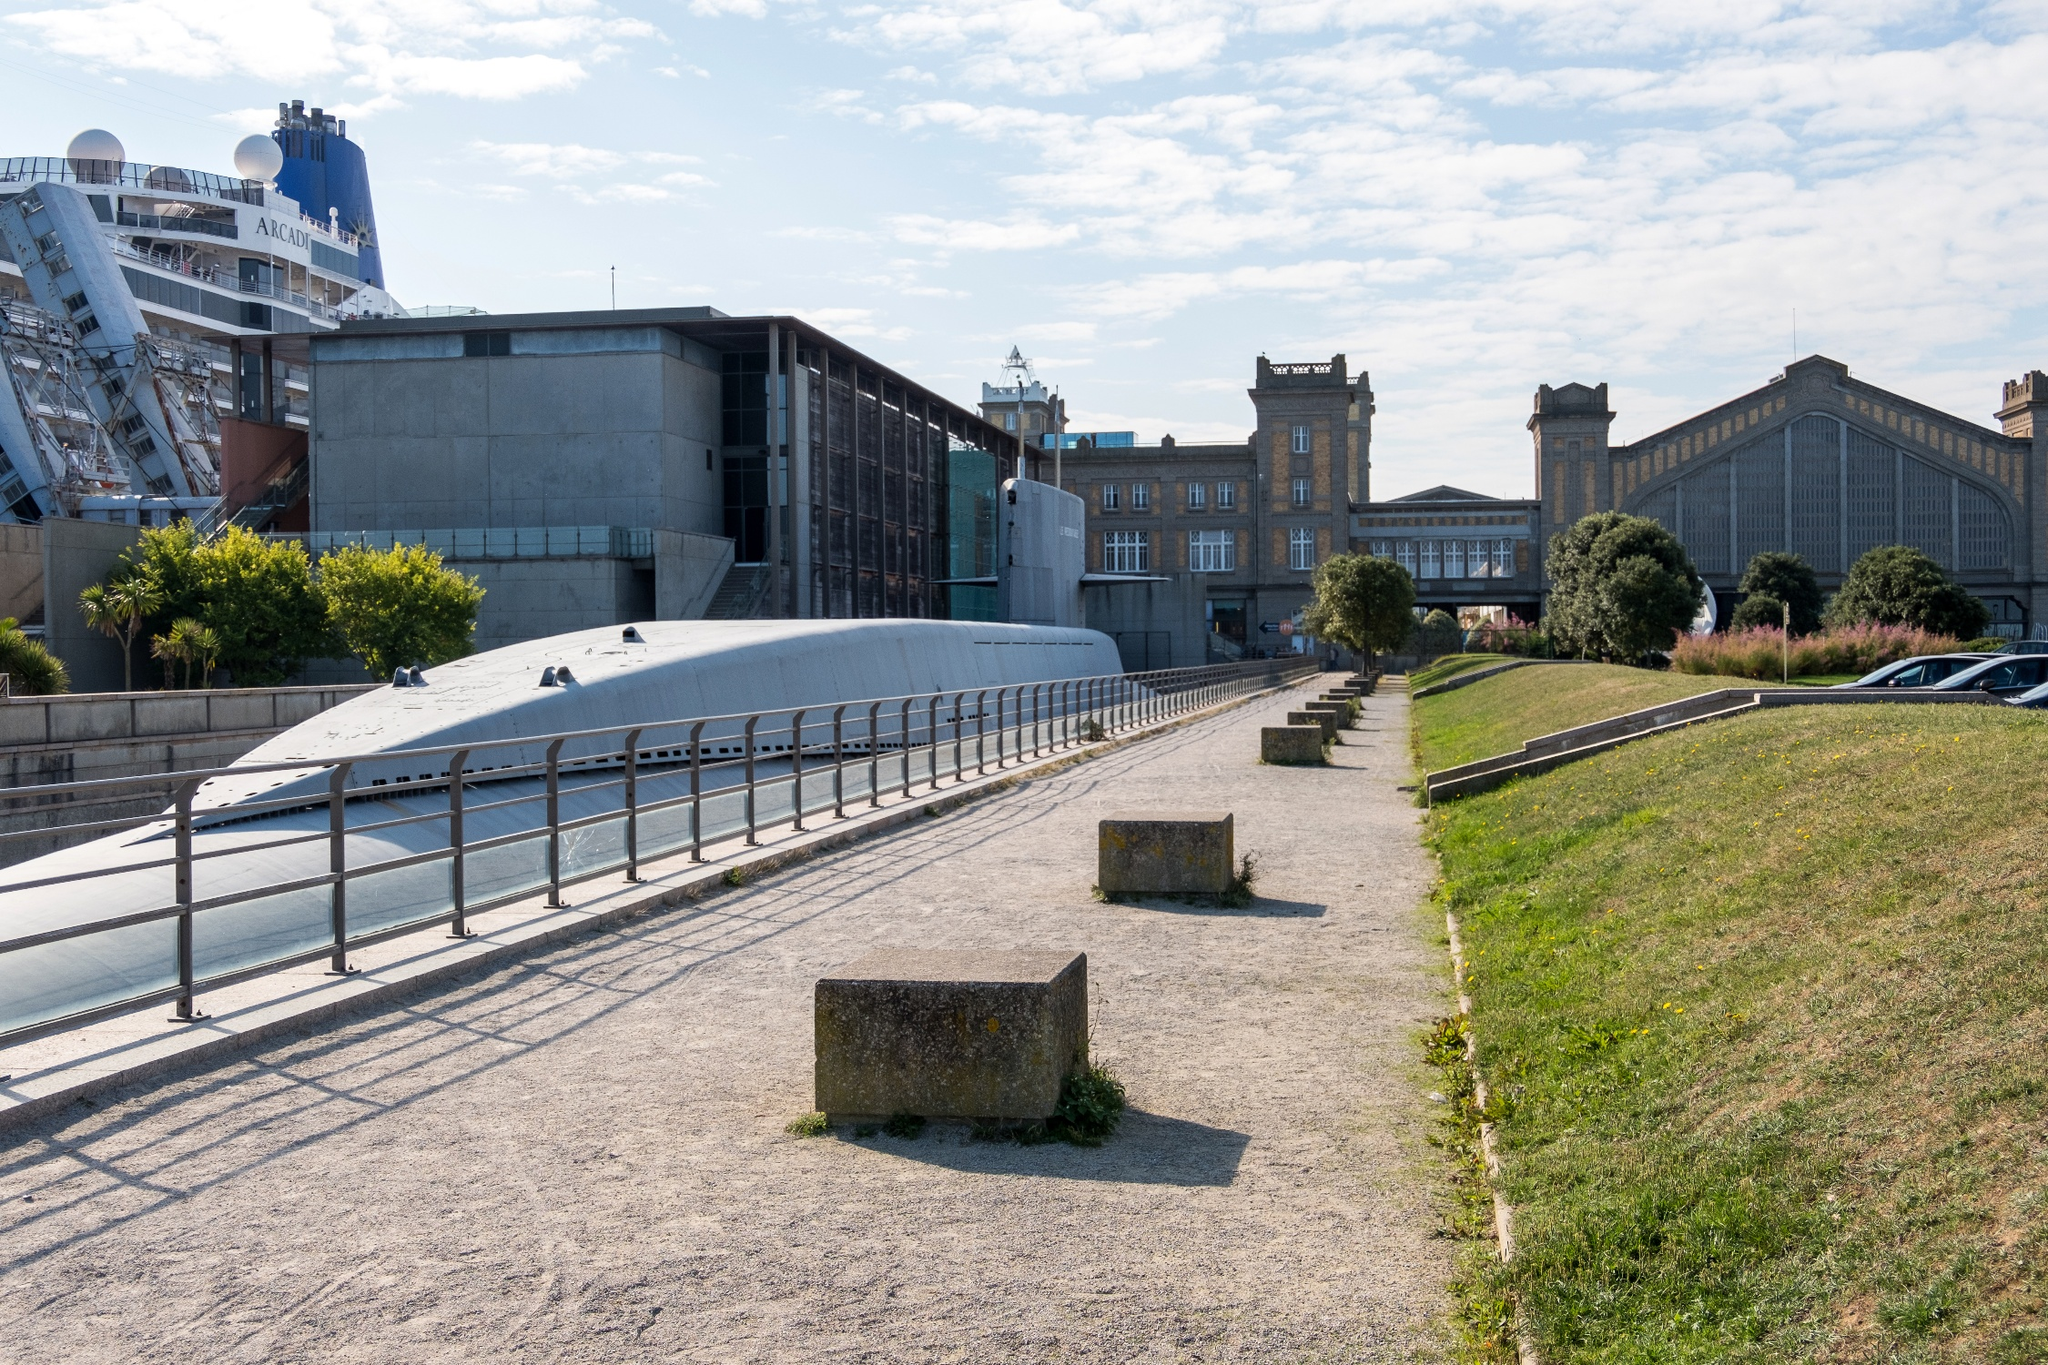What do you see happening in this image? The image captures a peaceful and sunny day in Cherbourg-Octeville, located in Normandy, France. From the viewpoint of a pedestrian walkway, the scene invites viewers to explore the city's blend of old and new architecture. The walkway features concrete benches and is lined with patches of grass, creating a relaxing ambiance. Noteworthy is the monumental building in the background, likely an industrial or maritime facility, which showcases the city's maritime heritage. Additionally, there is a cruise ship docked at the port, adding to Cherbourg's bustling maritime activities. The clear blue sky complements the tranquil environment, highlighting a harmonious blend of urban and natural elements within the city. 